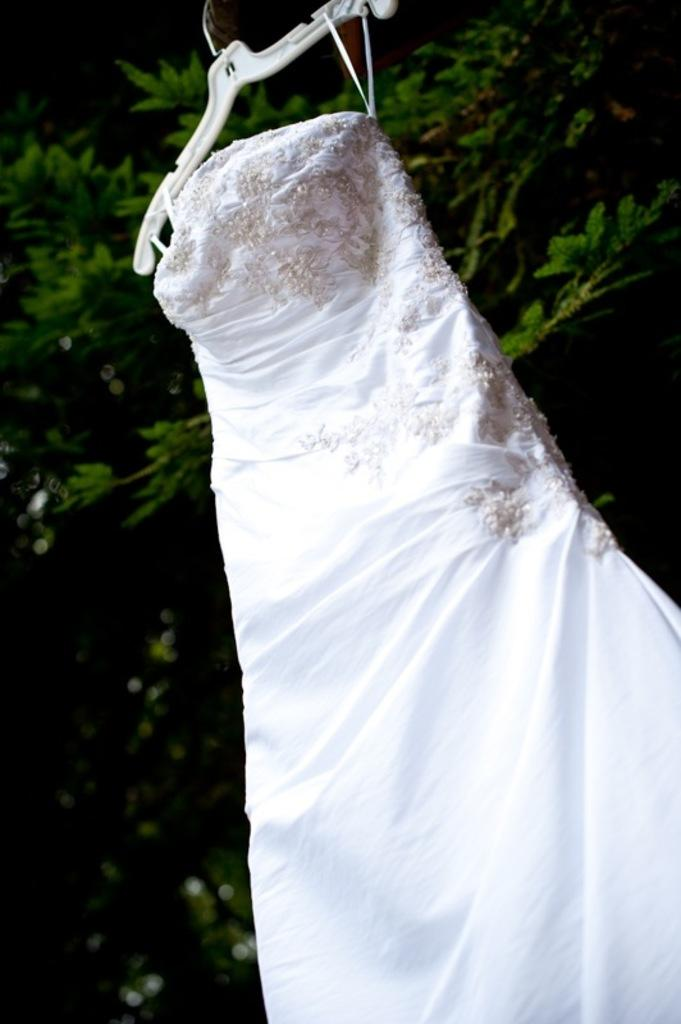What can be seen hanging in the image? There is an object hanged on the hanger in the image. What is the object used for? The hanger is used for hanging objects, but the specific purpose of the object on the hanger is not mentioned in the facts. What can be seen in the background of the image? There is a tree visible in the background of the image. What type of authority is depicted in the image? There is no authority figure present in the image; it only features a hanger with an object on it and a tree in the background. 